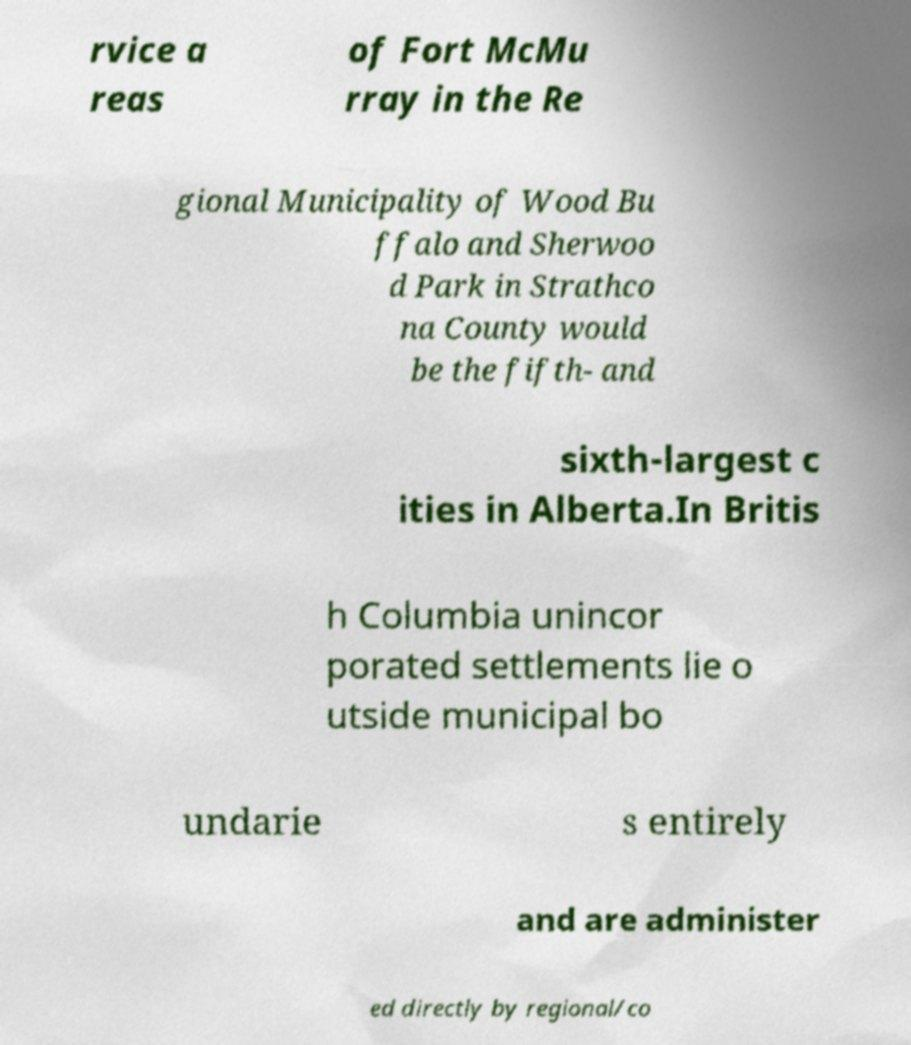Could you extract and type out the text from this image? rvice a reas of Fort McMu rray in the Re gional Municipality of Wood Bu ffalo and Sherwoo d Park in Strathco na County would be the fifth- and sixth-largest c ities in Alberta.In Britis h Columbia unincor porated settlements lie o utside municipal bo undarie s entirely and are administer ed directly by regional/co 